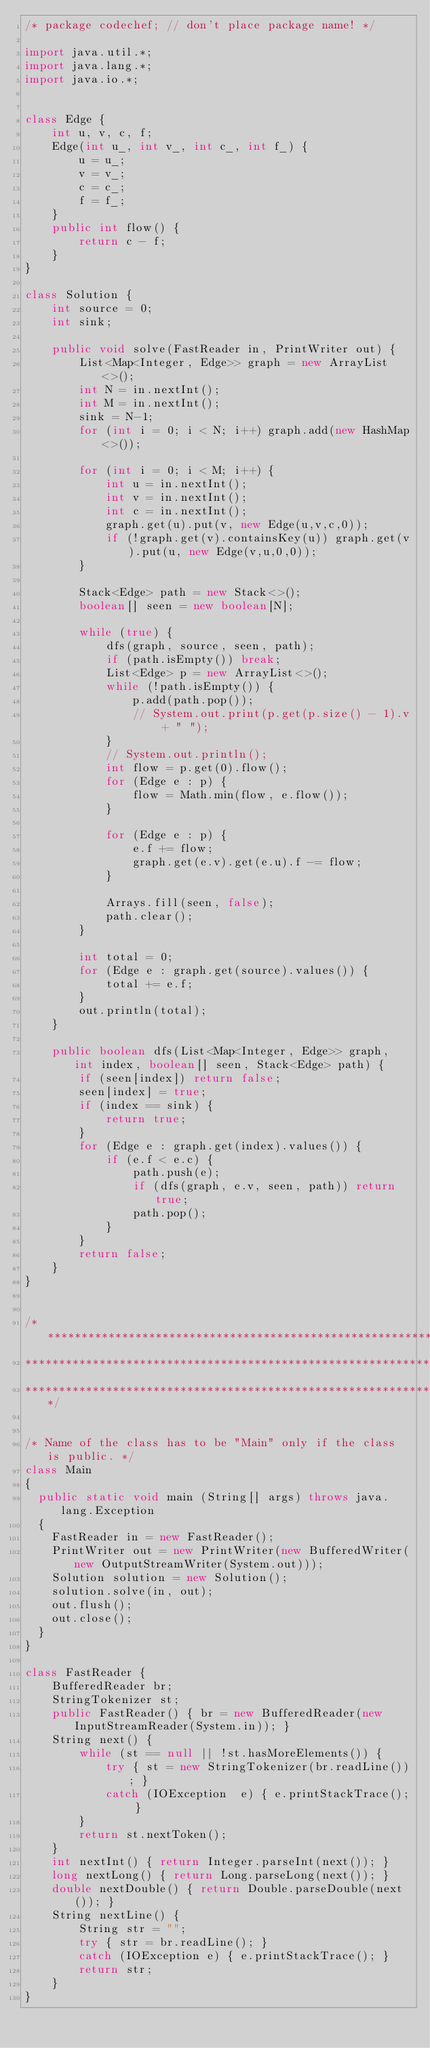Convert code to text. <code><loc_0><loc_0><loc_500><loc_500><_Java_>/* package codechef; // don't place package name! */

import java.util.*;
import java.lang.*;
import java.io.*;


class Edge {
    int u, v, c, f;
    Edge(int u_, int v_, int c_, int f_) {
        u = u_;
        v = v_;
        c = c_;
        f = f_;
    }
    public int flow() {
        return c - f;
    }
}

class Solution {
    int source = 0;
    int sink;
    
    public void solve(FastReader in, PrintWriter out) {
        List<Map<Integer, Edge>> graph = new ArrayList<>();
        int N = in.nextInt();
        int M = in.nextInt();
        sink = N-1;
        for (int i = 0; i < N; i++) graph.add(new HashMap<>());

        for (int i = 0; i < M; i++) {
            int u = in.nextInt();
            int v = in.nextInt();
            int c = in.nextInt();
            graph.get(u).put(v, new Edge(u,v,c,0));
            if (!graph.get(v).containsKey(u)) graph.get(v).put(u, new Edge(v,u,0,0));
        }

        Stack<Edge> path = new Stack<>();
        boolean[] seen = new boolean[N];

        while (true) {
            dfs(graph, source, seen, path);
            if (path.isEmpty()) break;
            List<Edge> p = new ArrayList<>();
            while (!path.isEmpty()) {
                p.add(path.pop());
                // System.out.print(p.get(p.size() - 1).v + " ");
            }
            // System.out.println();
            int flow = p.get(0).flow();
            for (Edge e : p) {
                flow = Math.min(flow, e.flow());
            }

            for (Edge e : p) {
                e.f += flow;
                graph.get(e.v).get(e.u).f -= flow;
            }

            Arrays.fill(seen, false);
            path.clear();
        }

        int total = 0;
        for (Edge e : graph.get(source).values()) {
            total += e.f;
        }
        out.println(total);
    }

    public boolean dfs(List<Map<Integer, Edge>> graph, int index, boolean[] seen, Stack<Edge> path) {
        if (seen[index]) return false;
        seen[index] = true;
        if (index == sink) {
            return true;
        }
        for (Edge e : graph.get(index).values()) {
            if (e.f < e.c) {
                path.push(e);
                if (dfs(graph, e.v, seen, path)) return true;
                path.pop();
            }
        }
        return false;
    }
}


/*******************************************************************************
********************************************************************************
********************************************************************************/


/* Name of the class has to be "Main" only if the class is public. */
class Main
{
	public static void main (String[] args) throws java.lang.Exception
	{
		FastReader in = new FastReader();
		PrintWriter out = new PrintWriter(new BufferedWriter(new OutputStreamWriter(System.out)));
		Solution solution = new Solution();
		solution.solve(in, out);
		out.flush();
		out.close();
	}
}

class FastReader {
    BufferedReader br;
    StringTokenizer st;
    public FastReader() { br = new BufferedReader(new InputStreamReader(System.in)); }
    String next() {
        while (st == null || !st.hasMoreElements()) {
            try { st = new StringTokenizer(br.readLine()); }
            catch (IOException  e) { e.printStackTrace(); }
        }
        return st.nextToken();
    }
    int nextInt() { return Integer.parseInt(next()); }
    long nextLong() { return Long.parseLong(next()); }
    double nextDouble() { return Double.parseDouble(next()); }
    String nextLine() {
        String str = "";
        try { str = br.readLine(); }
        catch (IOException e) { e.printStackTrace(); }
        return str;
    }
}

</code> 